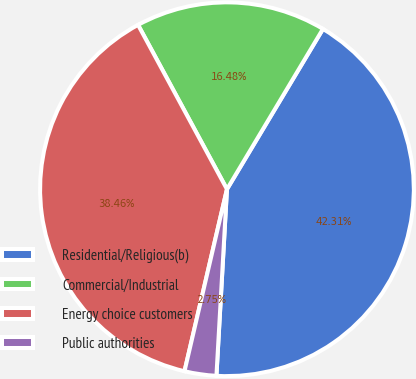<chart> <loc_0><loc_0><loc_500><loc_500><pie_chart><fcel>Residential/Religious(b)<fcel>Commercial/Industrial<fcel>Energy choice customers<fcel>Public authorities<nl><fcel>42.31%<fcel>16.48%<fcel>38.46%<fcel>2.75%<nl></chart> 